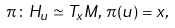<formula> <loc_0><loc_0><loc_500><loc_500>\pi \colon H _ { u } \simeq T _ { x } M , \, \pi ( u ) = x ,</formula> 